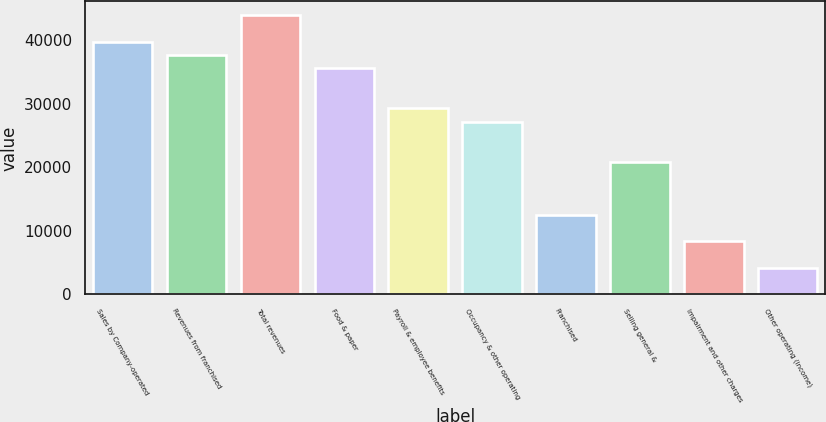Convert chart. <chart><loc_0><loc_0><loc_500><loc_500><bar_chart><fcel>Sales by Company-operated<fcel>Revenues from franchised<fcel>Total revenues<fcel>Food & paper<fcel>Payroll & employee benefits<fcel>Occupancy & other operating<fcel>Franchised<fcel>Selling general &<fcel>Impairment and other charges<fcel>Other operating (income)<nl><fcel>39700<fcel>37610.6<fcel>43878.8<fcel>35521.1<fcel>29252.9<fcel>27163.5<fcel>12537.5<fcel>20895.2<fcel>8358.68<fcel>4179.84<nl></chart> 